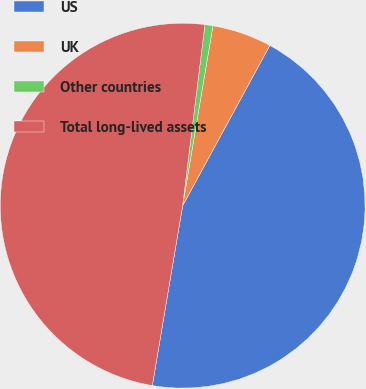Convert chart to OTSL. <chart><loc_0><loc_0><loc_500><loc_500><pie_chart><fcel>US<fcel>UK<fcel>Other countries<fcel>Total long-lived assets<nl><fcel>44.73%<fcel>5.27%<fcel>0.71%<fcel>49.29%<nl></chart> 